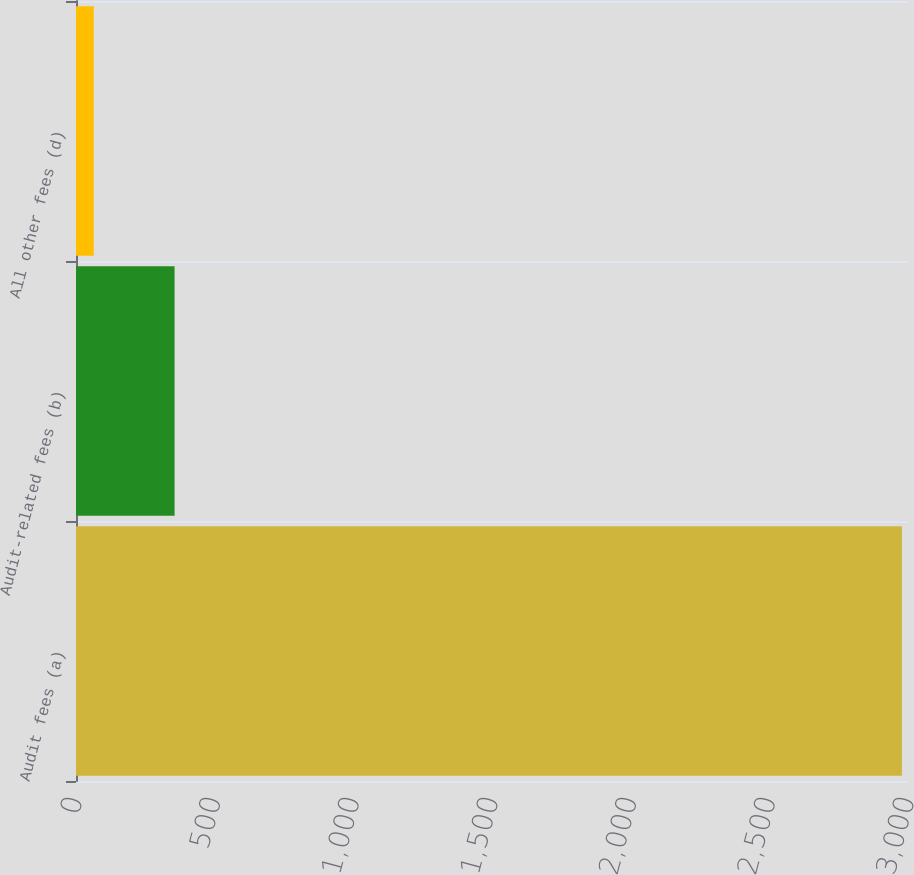<chart> <loc_0><loc_0><loc_500><loc_500><bar_chart><fcel>Audit fees (a)<fcel>Audit-related fees (b)<fcel>All other fees (d)<nl><fcel>2978<fcel>355.4<fcel>64<nl></chart> 